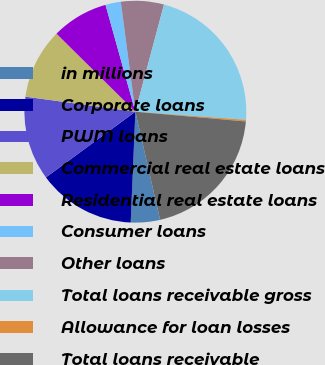Convert chart to OTSL. <chart><loc_0><loc_0><loc_500><loc_500><pie_chart><fcel>in millions<fcel>Corporate loans<fcel>PWM loans<fcel>Commercial real estate loans<fcel>Residential real estate loans<fcel>Consumer loans<fcel>Other loans<fcel>Total loans receivable gross<fcel>Allowance for loan losses<fcel>Total loans receivable<nl><fcel>4.25%<fcel>14.25%<fcel>12.25%<fcel>10.25%<fcel>8.25%<fcel>2.24%<fcel>6.25%<fcel>22.01%<fcel>0.24%<fcel>20.01%<nl></chart> 